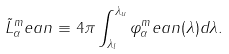Convert formula to latex. <formula><loc_0><loc_0><loc_500><loc_500>\tilde { L } _ { \alpha } ^ { m } e a n \equiv 4 \pi \int ^ { \lambda _ { u } } _ { \lambda _ { l } } \varphi _ { \alpha } ^ { m } e a n ( \lambda ) d \lambda .</formula> 